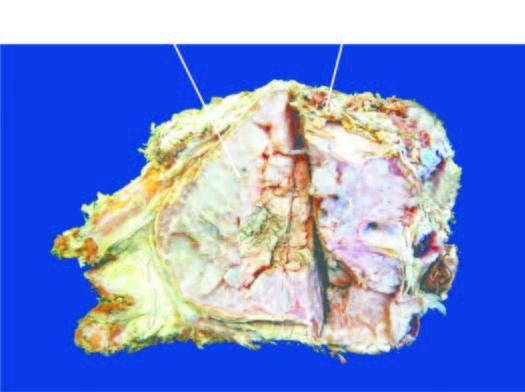why is the bone expanded?
Answer the question using a single word or phrase. Due to a gelatinous tumour 